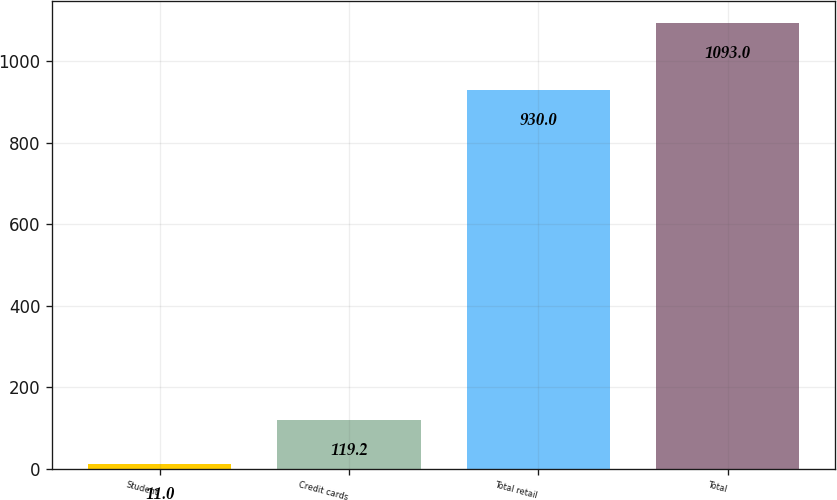Convert chart to OTSL. <chart><loc_0><loc_0><loc_500><loc_500><bar_chart><fcel>Student<fcel>Credit cards<fcel>Total retail<fcel>Total<nl><fcel>11<fcel>119.2<fcel>930<fcel>1093<nl></chart> 